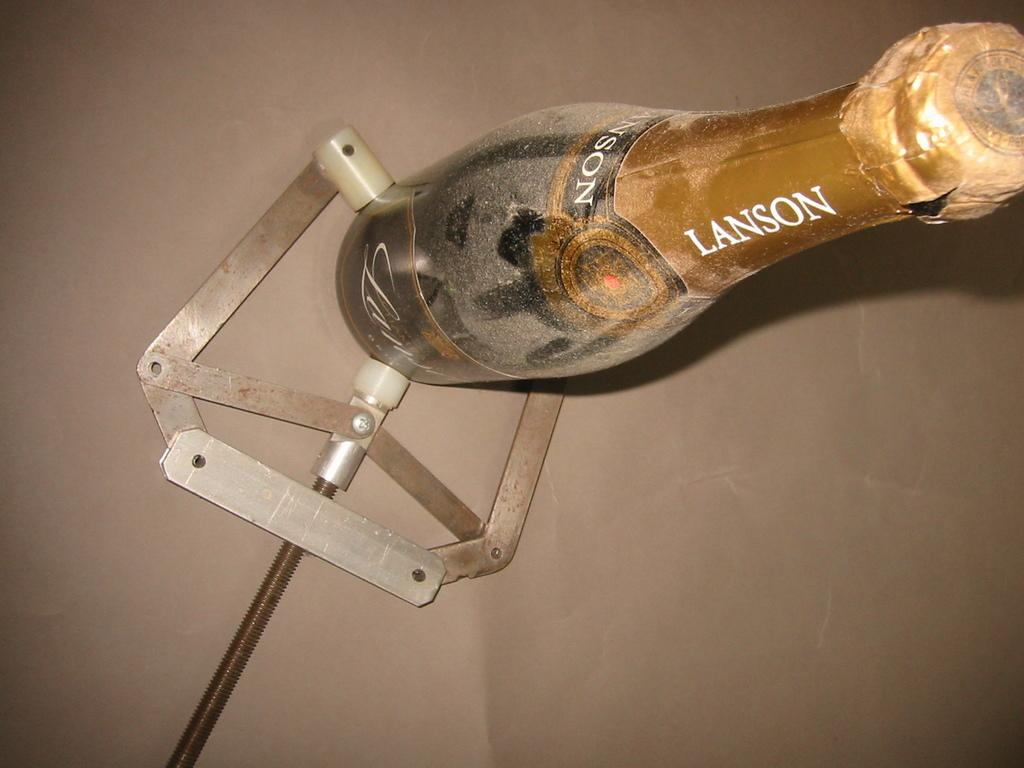<image>
Share a concise interpretation of the image provided. A bottle of lanson champagne is ssen from above. 